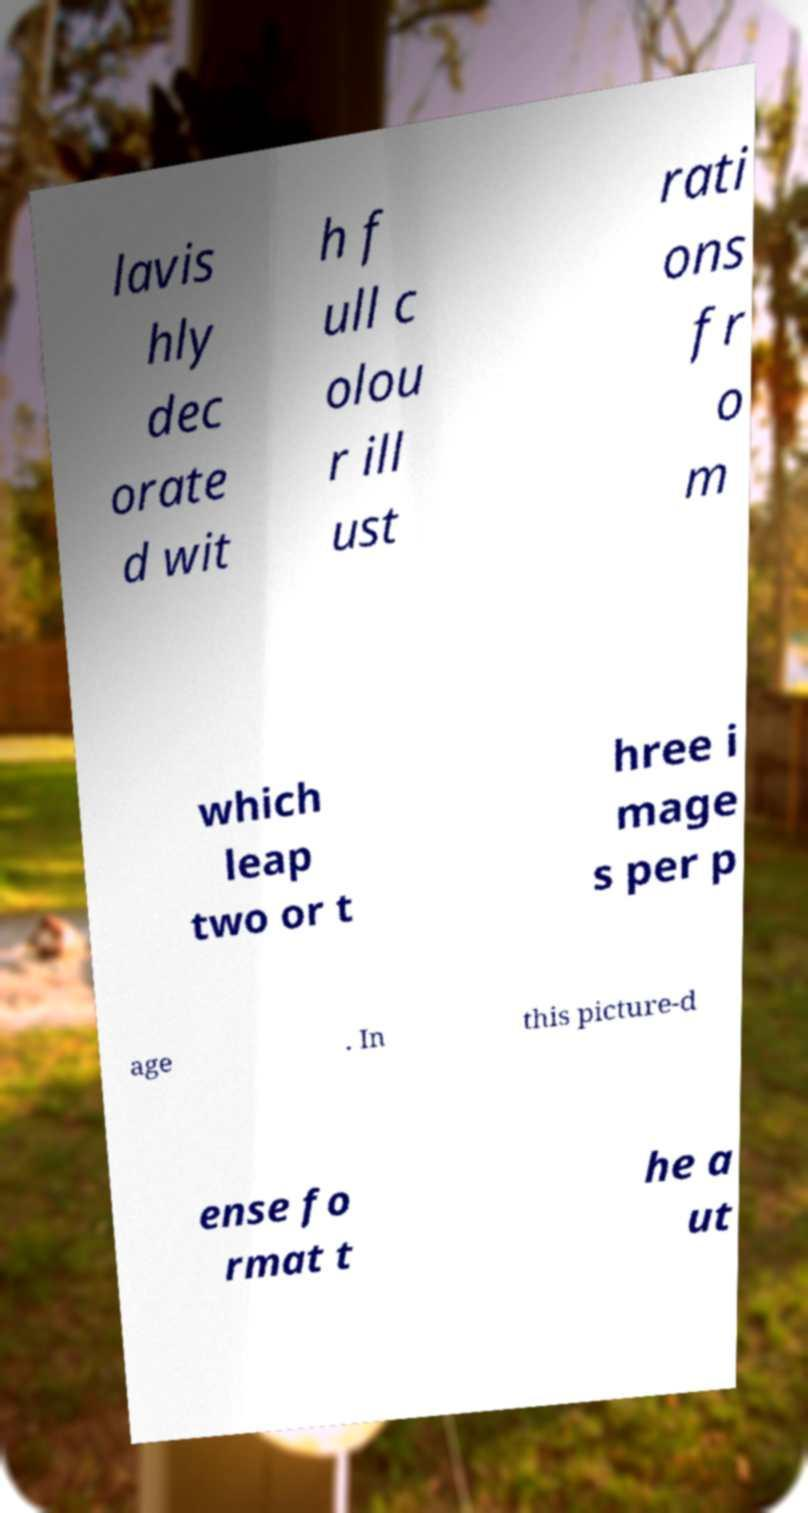For documentation purposes, I need the text within this image transcribed. Could you provide that? lavis hly dec orate d wit h f ull c olou r ill ust rati ons fr o m which leap two or t hree i mage s per p age . In this picture-d ense fo rmat t he a ut 